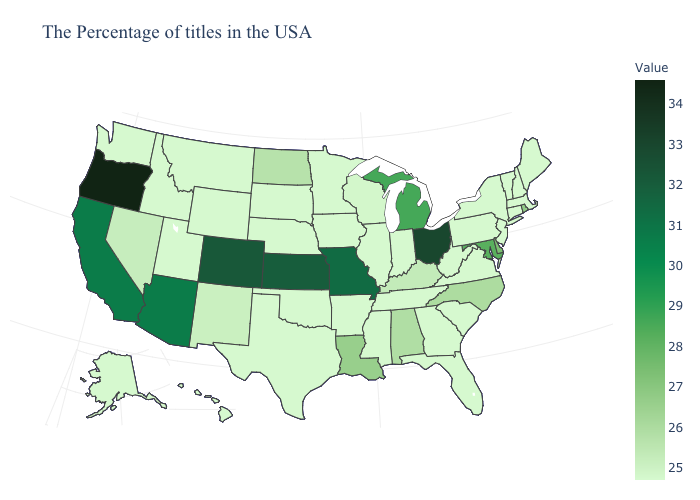Does Arizona have the lowest value in the West?
Be succinct. No. Does Oregon have a lower value than Delaware?
Give a very brief answer. No. Is the legend a continuous bar?
Short answer required. Yes. Which states hav the highest value in the Northeast?
Give a very brief answer. Rhode Island. 